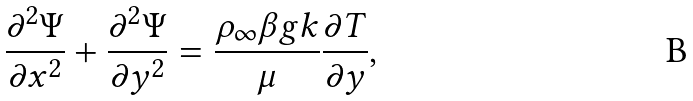Convert formula to latex. <formula><loc_0><loc_0><loc_500><loc_500>\frac { \partial ^ { 2 } \Psi } { \partial x ^ { 2 } } + \frac { \partial ^ { 2 } \Psi } { \partial y ^ { 2 } } = \frac { \rho _ { \infty } \beta g k } { \mu } \frac { \partial T } { \partial y } ,</formula> 